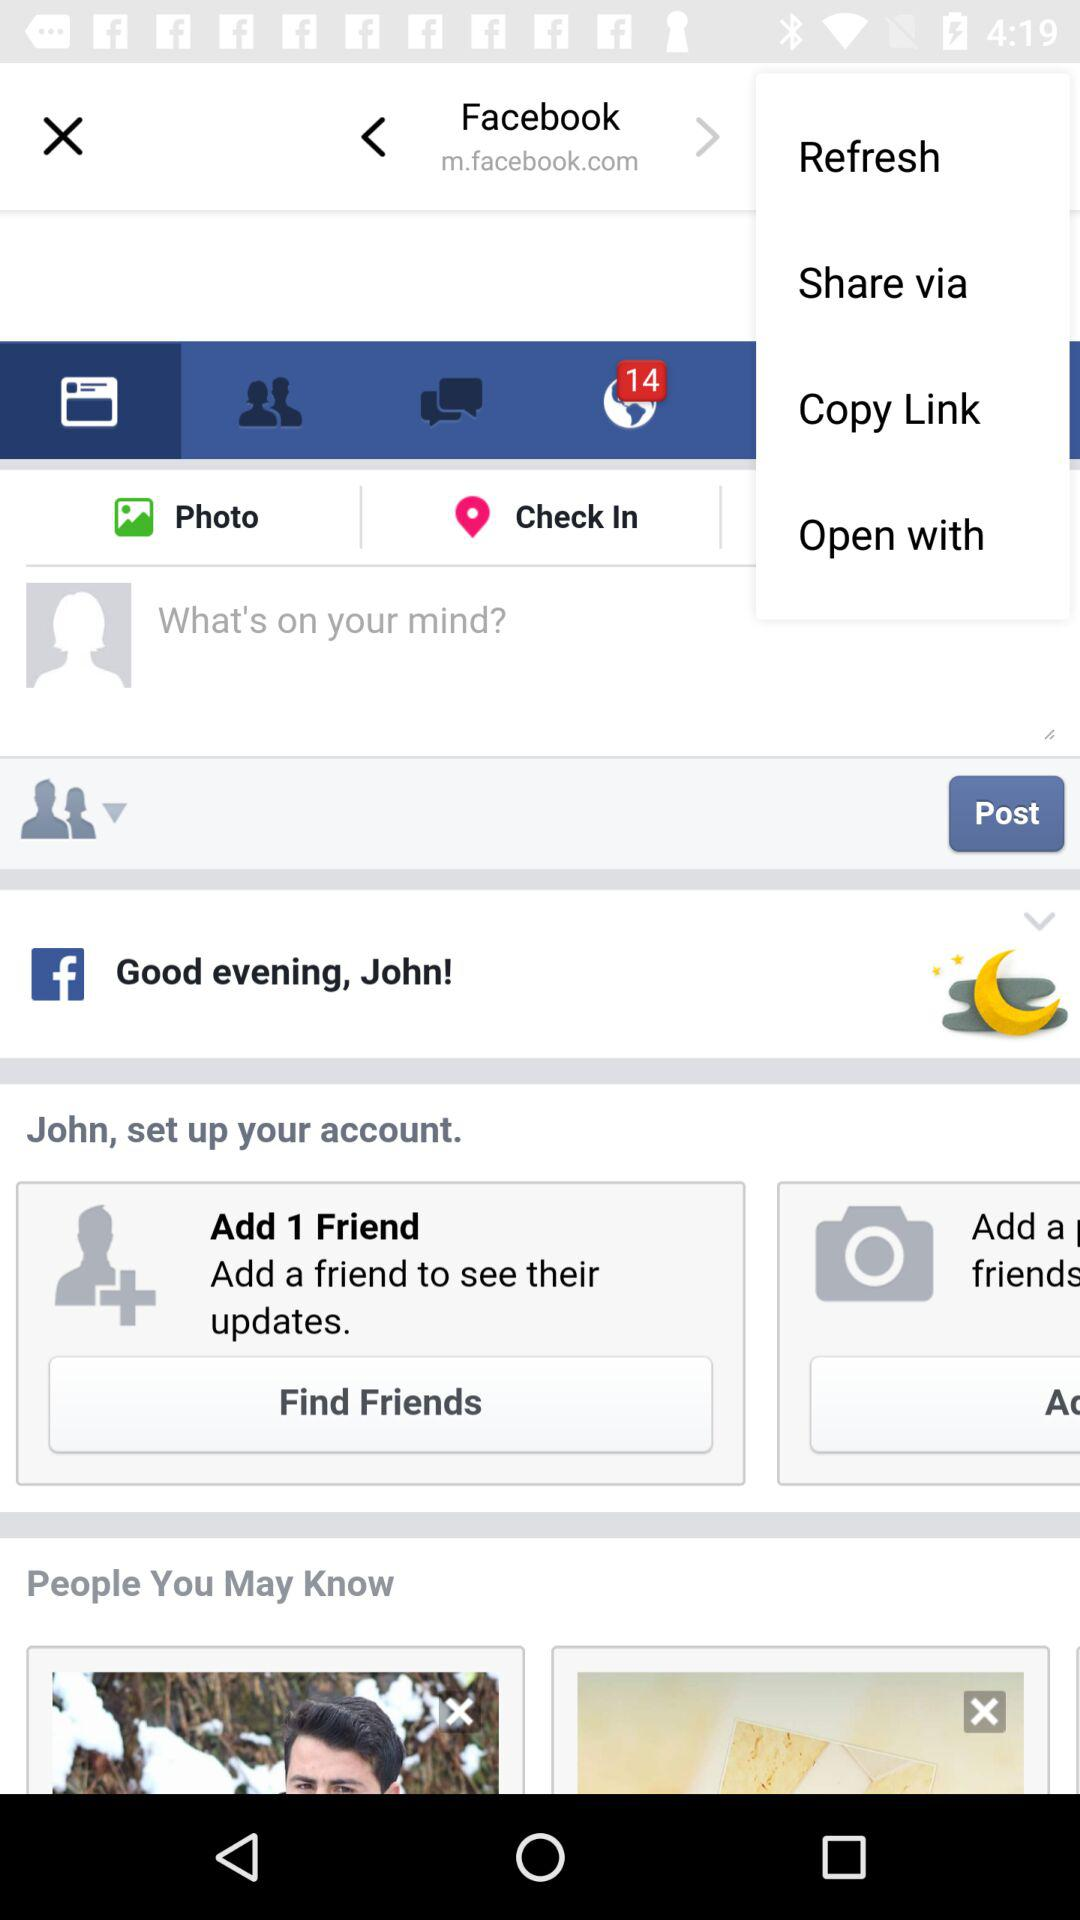With who can the link be shared?
When the provided information is insufficient, respond with <no answer>. <no answer> 